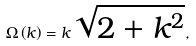Convert formula to latex. <formula><loc_0><loc_0><loc_500><loc_500>\Omega \left ( k \right ) = k \sqrt { 2 + k ^ { 2 } } ,</formula> 